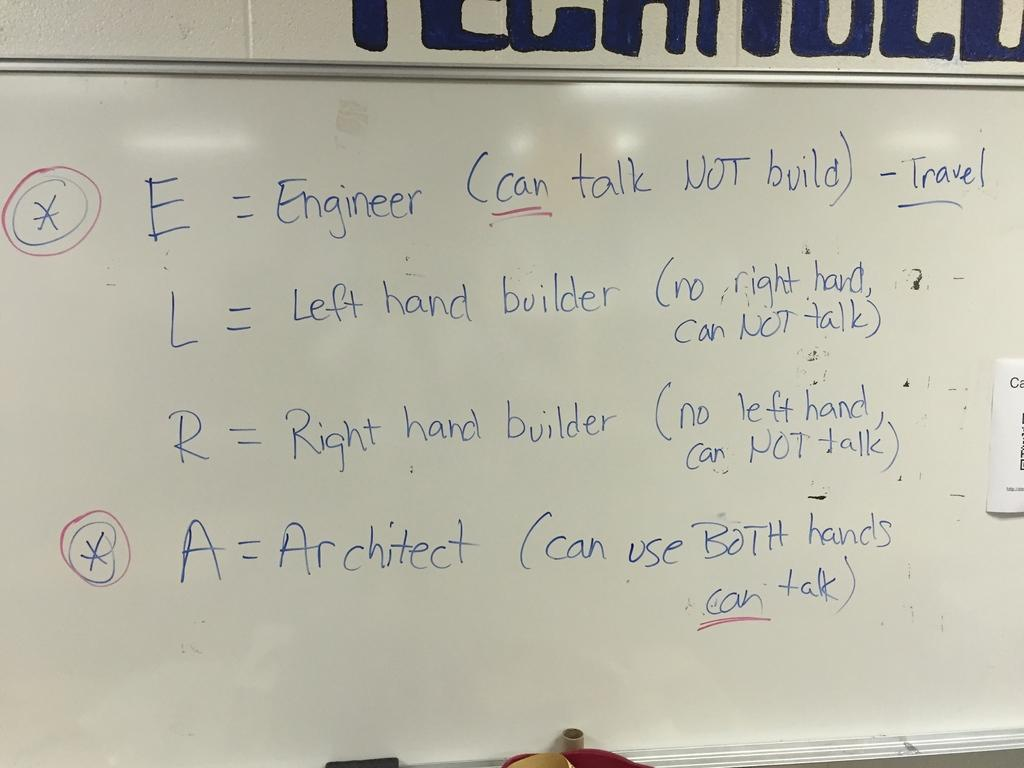<image>
Describe the image concisely. A whiteboard displays that an engineer can talk, but not build. 